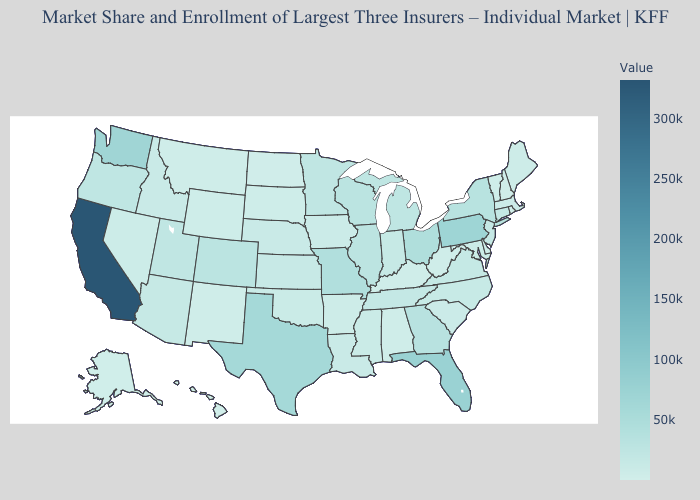Does Massachusetts have the lowest value in the Northeast?
Be succinct. No. Among the states that border North Dakota , which have the lowest value?
Be succinct. Montana. Among the states that border New Mexico , which have the lowest value?
Give a very brief answer. Oklahoma. Which states have the lowest value in the USA?
Quick response, please. Rhode Island. Does the map have missing data?
Keep it brief. No. Does California have the lowest value in the USA?
Quick response, please. No. Does Indiana have the highest value in the USA?
Give a very brief answer. No. Which states hav the highest value in the West?
Give a very brief answer. California. 